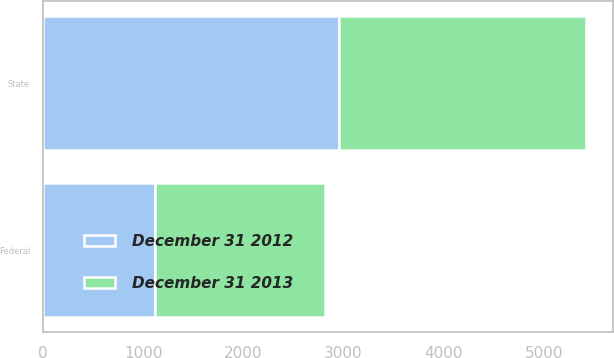<chart> <loc_0><loc_0><loc_500><loc_500><stacked_bar_chart><ecel><fcel>Federal<fcel>State<nl><fcel>December 31 2012<fcel>1116<fcel>2958<nl><fcel>December 31 2013<fcel>1698<fcel>2468<nl></chart> 